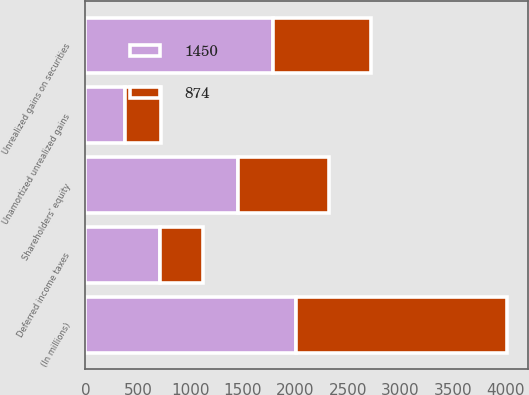Convert chart to OTSL. <chart><loc_0><loc_0><loc_500><loc_500><stacked_bar_chart><ecel><fcel>(In millions)<fcel>Unrealized gains on securities<fcel>Unamortized unrealized gains<fcel>Deferred income taxes<fcel>Shareholders' equity<nl><fcel>874<fcel>2007<fcel>941<fcel>343<fcel>410<fcel>874<nl><fcel>1450<fcel>2006<fcel>1783<fcel>378<fcel>711<fcel>1450<nl></chart> 